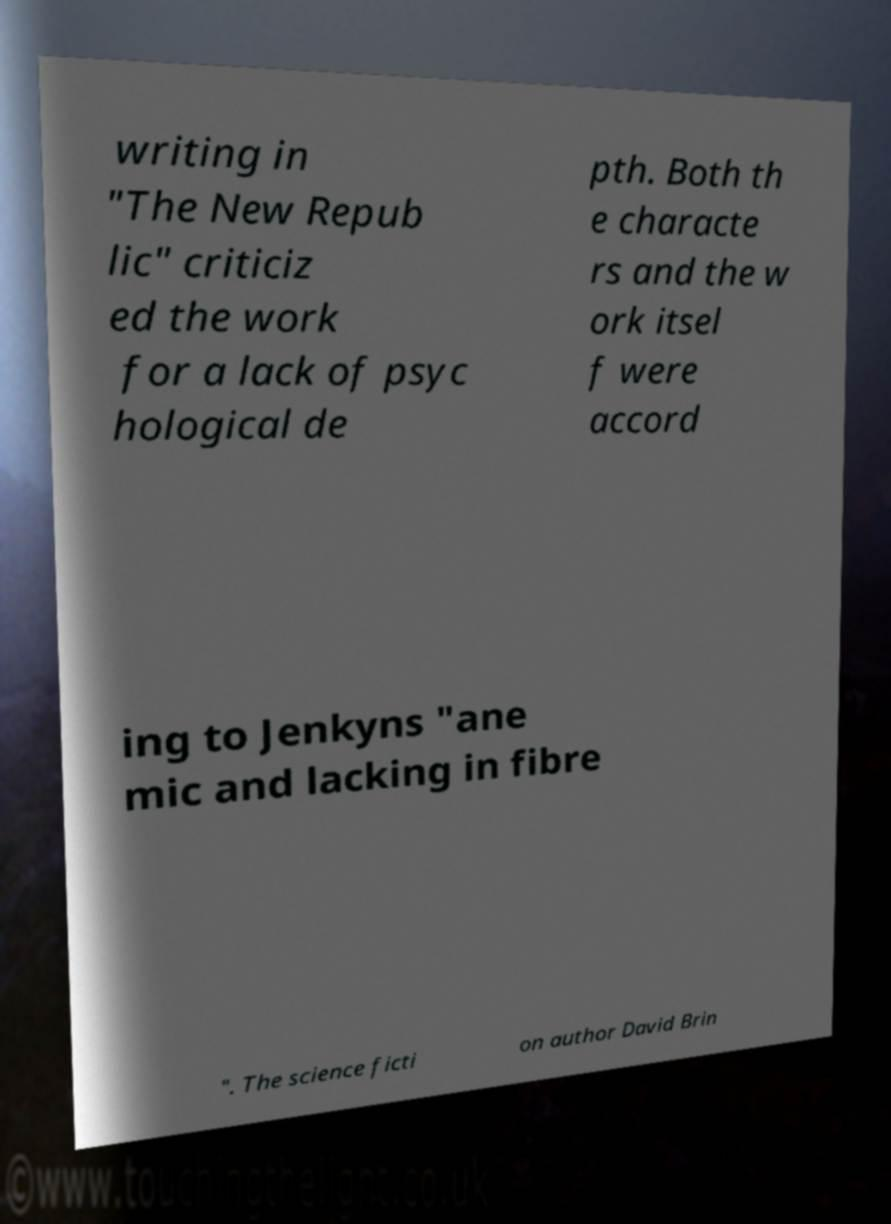Could you extract and type out the text from this image? writing in "The New Repub lic" criticiz ed the work for a lack of psyc hological de pth. Both th e characte rs and the w ork itsel f were accord ing to Jenkyns "ane mic and lacking in fibre ". The science ficti on author David Brin 